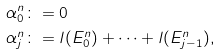<formula> <loc_0><loc_0><loc_500><loc_500>& \alpha ^ { n } _ { 0 } \colon = 0 \\ & \alpha ^ { n } _ { j } \colon = l ( E ^ { n } _ { 0 } ) + \dots + l ( E ^ { n } _ { j - 1 } ) ,</formula> 